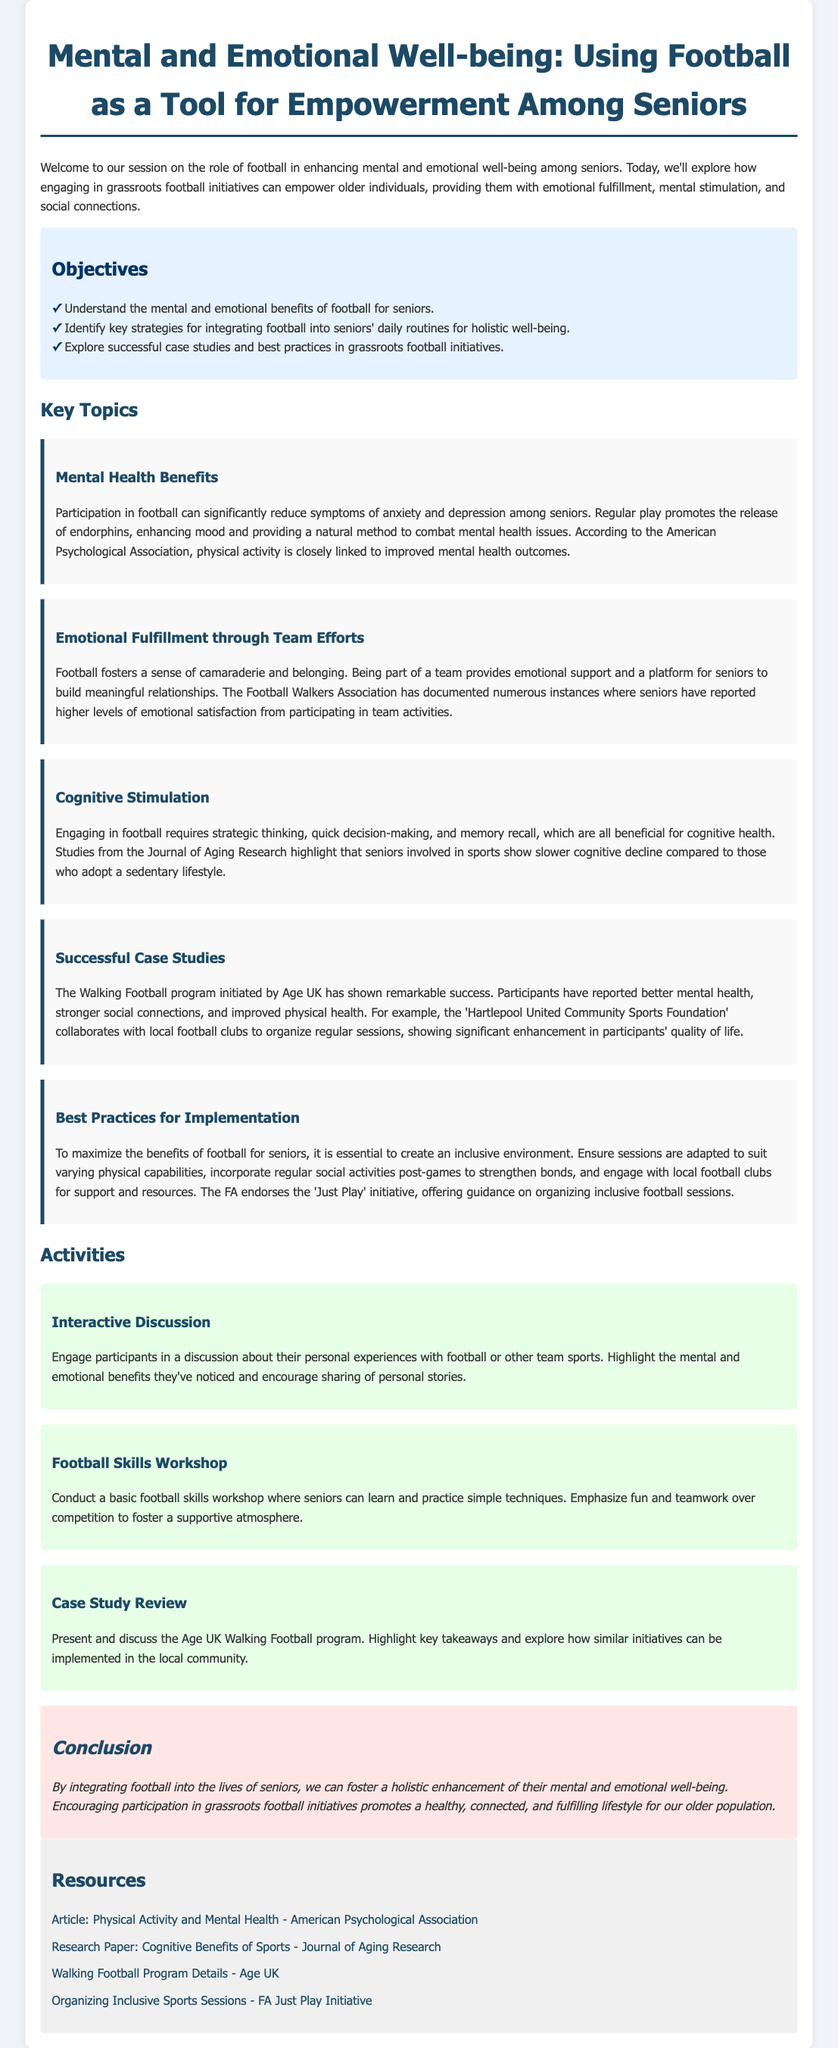What are the objectives of the session? The objectives are listed in a bulleted format under Objectives in the document, outlining what participants should learn.
Answer: Understand the mental and emotional benefits of football for seniors, Identify key strategies for integrating football into seniors' daily routines for holistic well-being, Explore successful case studies and best practices in grassroots football initiatives What is one mental health benefit of participating in football? The document describes mental health benefits in the section on Mental Health Benefits, specifying the positive effects on seniors.
Answer: Reduce symptoms of anxiety and depression What organization documented emotional fulfillment through team efforts? The document references an organization that has noted positive emotional feedback from seniors participating in team activities.
Answer: Football Walkers Association What is the title of the case study reviewing a successful program? The document includes a section on a successful case study that serves as an example related to football initiatives.
Answer: Walking Football program initiated by Age UK What is a key strategy for implementing football for seniors? The document includes recommendations in the Best Practices for Implementation section on how to maximize the benefits of football among seniors.
Answer: Create an inclusive environment How many key topics are discussed in the lesson plan? The document lists four main topics under Key Topics which are issues addressed in relation to football and its impact on seniors.
Answer: Five What is a suggested activity within the lesson plan? The Activities section details various activities that can be implemented during the session to engage participants.
Answer: Interactive Discussion What type of well-being is emphasized in the conclusion? The conclusion summarizes the overall aim of incorporating football, focusing on a particular type of well-being.
Answer: Mental and emotional well-being 